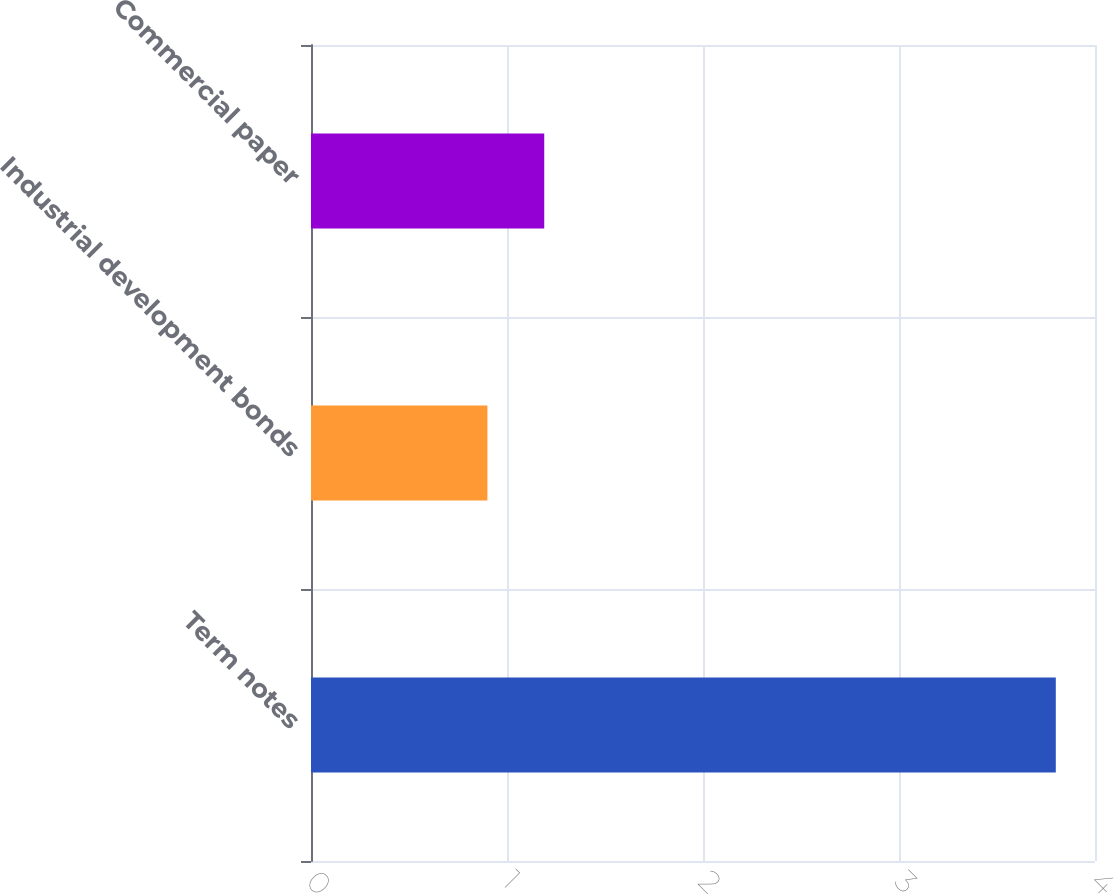Convert chart to OTSL. <chart><loc_0><loc_0><loc_500><loc_500><bar_chart><fcel>Term notes<fcel>Industrial development bonds<fcel>Commercial paper<nl><fcel>3.8<fcel>0.9<fcel>1.19<nl></chart> 